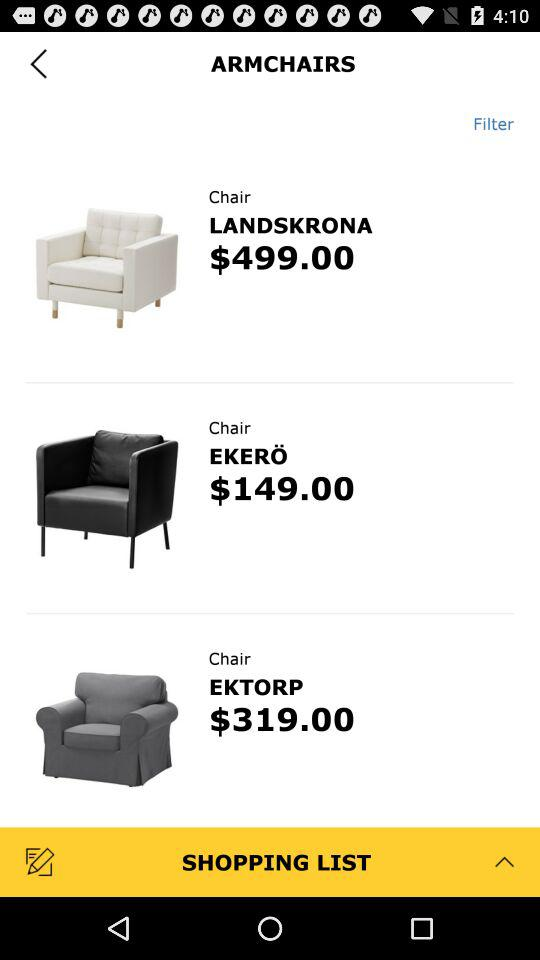What is the price of the chair "LANDSKRONA"? The price of the chair "LANDSKRONA" is $499. 